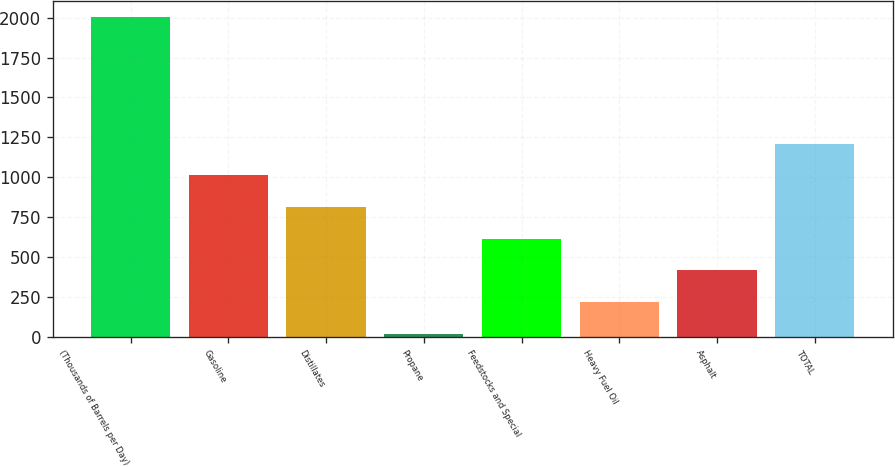Convert chart to OTSL. <chart><loc_0><loc_0><loc_500><loc_500><bar_chart><fcel>(Thousands of Barrels per Day)<fcel>Gasoline<fcel>Distillates<fcel>Propane<fcel>Feedstocks and Special<fcel>Heavy Fuel Oil<fcel>Asphalt<fcel>TOTAL<nl><fcel>2003<fcel>1012<fcel>813.8<fcel>21<fcel>615.6<fcel>219.2<fcel>417.4<fcel>1210.2<nl></chart> 